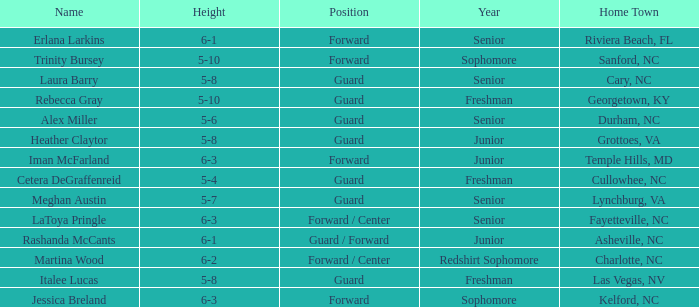In what year of school is the player from Fayetteville, NC? Senior. 